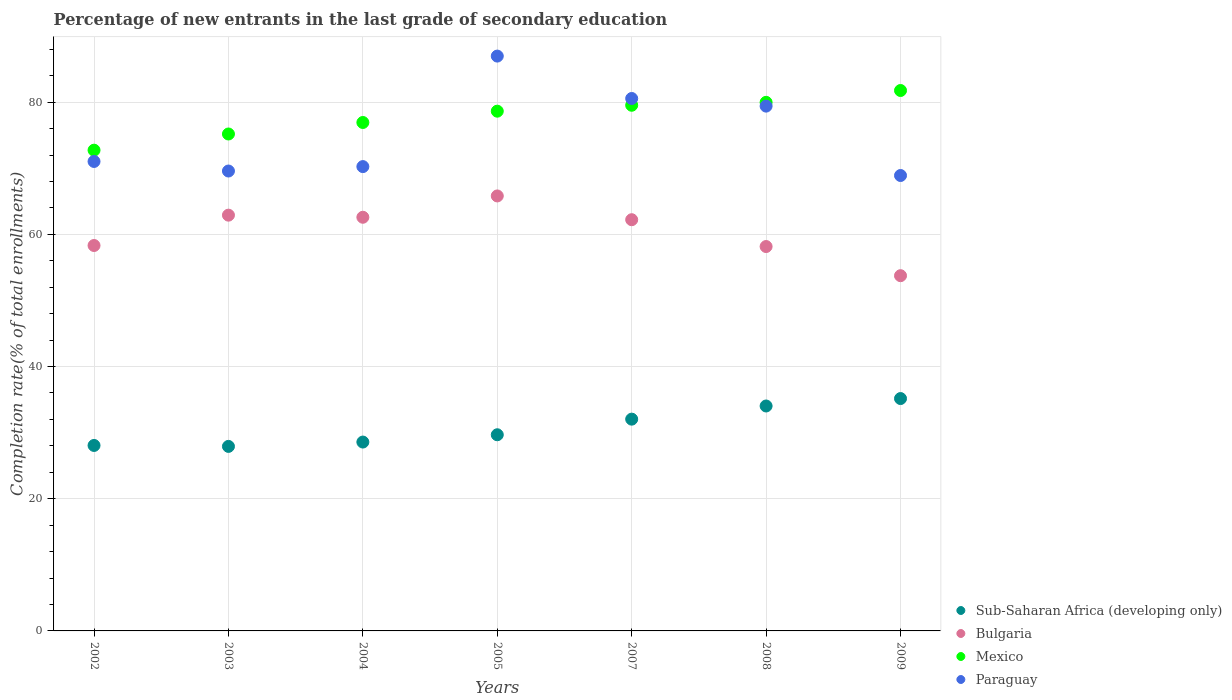How many different coloured dotlines are there?
Offer a terse response. 4. Is the number of dotlines equal to the number of legend labels?
Offer a terse response. Yes. What is the percentage of new entrants in Paraguay in 2007?
Give a very brief answer. 80.55. Across all years, what is the maximum percentage of new entrants in Bulgaria?
Your response must be concise. 65.81. Across all years, what is the minimum percentage of new entrants in Paraguay?
Offer a very short reply. 68.9. In which year was the percentage of new entrants in Sub-Saharan Africa (developing only) maximum?
Keep it short and to the point. 2009. In which year was the percentage of new entrants in Paraguay minimum?
Your answer should be very brief. 2009. What is the total percentage of new entrants in Paraguay in the graph?
Provide a succinct answer. 526.67. What is the difference between the percentage of new entrants in Mexico in 2002 and that in 2004?
Give a very brief answer. -4.19. What is the difference between the percentage of new entrants in Mexico in 2003 and the percentage of new entrants in Paraguay in 2007?
Offer a very short reply. -5.37. What is the average percentage of new entrants in Mexico per year?
Provide a succinct answer. 77.82. In the year 2004, what is the difference between the percentage of new entrants in Sub-Saharan Africa (developing only) and percentage of new entrants in Mexico?
Keep it short and to the point. -48.35. In how many years, is the percentage of new entrants in Paraguay greater than 64 %?
Your answer should be very brief. 7. What is the ratio of the percentage of new entrants in Mexico in 2002 to that in 2007?
Give a very brief answer. 0.91. Is the percentage of new entrants in Bulgaria in 2004 less than that in 2007?
Offer a terse response. No. Is the difference between the percentage of new entrants in Sub-Saharan Africa (developing only) in 2005 and 2009 greater than the difference between the percentage of new entrants in Mexico in 2005 and 2009?
Your response must be concise. No. What is the difference between the highest and the second highest percentage of new entrants in Sub-Saharan Africa (developing only)?
Make the answer very short. 1.12. What is the difference between the highest and the lowest percentage of new entrants in Sub-Saharan Africa (developing only)?
Give a very brief answer. 7.24. Is it the case that in every year, the sum of the percentage of new entrants in Sub-Saharan Africa (developing only) and percentage of new entrants in Paraguay  is greater than the sum of percentage of new entrants in Mexico and percentage of new entrants in Bulgaria?
Offer a terse response. No. Does the percentage of new entrants in Mexico monotonically increase over the years?
Offer a very short reply. Yes. Is the percentage of new entrants in Sub-Saharan Africa (developing only) strictly greater than the percentage of new entrants in Mexico over the years?
Provide a succinct answer. No. How many years are there in the graph?
Make the answer very short. 7. What is the difference between two consecutive major ticks on the Y-axis?
Your answer should be compact. 20. Does the graph contain any zero values?
Keep it short and to the point. No. Where does the legend appear in the graph?
Make the answer very short. Bottom right. How many legend labels are there?
Your response must be concise. 4. What is the title of the graph?
Give a very brief answer. Percentage of new entrants in the last grade of secondary education. Does "Kazakhstan" appear as one of the legend labels in the graph?
Your answer should be compact. No. What is the label or title of the Y-axis?
Offer a terse response. Completion rate(% of total enrollments). What is the Completion rate(% of total enrollments) in Sub-Saharan Africa (developing only) in 2002?
Ensure brevity in your answer.  28.06. What is the Completion rate(% of total enrollments) in Bulgaria in 2002?
Your answer should be very brief. 58.31. What is the Completion rate(% of total enrollments) of Mexico in 2002?
Provide a short and direct response. 72.73. What is the Completion rate(% of total enrollments) of Paraguay in 2002?
Offer a very short reply. 71.03. What is the Completion rate(% of total enrollments) in Sub-Saharan Africa (developing only) in 2003?
Offer a terse response. 27.92. What is the Completion rate(% of total enrollments) in Bulgaria in 2003?
Offer a very short reply. 62.9. What is the Completion rate(% of total enrollments) in Mexico in 2003?
Provide a succinct answer. 75.18. What is the Completion rate(% of total enrollments) in Paraguay in 2003?
Give a very brief answer. 69.58. What is the Completion rate(% of total enrollments) of Sub-Saharan Africa (developing only) in 2004?
Offer a very short reply. 28.57. What is the Completion rate(% of total enrollments) of Bulgaria in 2004?
Give a very brief answer. 62.58. What is the Completion rate(% of total enrollments) of Mexico in 2004?
Provide a succinct answer. 76.92. What is the Completion rate(% of total enrollments) of Paraguay in 2004?
Offer a terse response. 70.25. What is the Completion rate(% of total enrollments) in Sub-Saharan Africa (developing only) in 2005?
Your response must be concise. 29.68. What is the Completion rate(% of total enrollments) of Bulgaria in 2005?
Offer a terse response. 65.81. What is the Completion rate(% of total enrollments) of Mexico in 2005?
Give a very brief answer. 78.63. What is the Completion rate(% of total enrollments) in Paraguay in 2005?
Your answer should be compact. 86.97. What is the Completion rate(% of total enrollments) in Sub-Saharan Africa (developing only) in 2007?
Your response must be concise. 32.04. What is the Completion rate(% of total enrollments) in Bulgaria in 2007?
Offer a terse response. 62.21. What is the Completion rate(% of total enrollments) of Mexico in 2007?
Your answer should be compact. 79.53. What is the Completion rate(% of total enrollments) in Paraguay in 2007?
Ensure brevity in your answer.  80.55. What is the Completion rate(% of total enrollments) of Sub-Saharan Africa (developing only) in 2008?
Ensure brevity in your answer.  34.03. What is the Completion rate(% of total enrollments) in Bulgaria in 2008?
Offer a terse response. 58.15. What is the Completion rate(% of total enrollments) of Mexico in 2008?
Your response must be concise. 79.97. What is the Completion rate(% of total enrollments) of Paraguay in 2008?
Offer a very short reply. 79.4. What is the Completion rate(% of total enrollments) in Sub-Saharan Africa (developing only) in 2009?
Your response must be concise. 35.15. What is the Completion rate(% of total enrollments) of Bulgaria in 2009?
Provide a short and direct response. 53.74. What is the Completion rate(% of total enrollments) of Mexico in 2009?
Offer a terse response. 81.76. What is the Completion rate(% of total enrollments) of Paraguay in 2009?
Keep it short and to the point. 68.9. Across all years, what is the maximum Completion rate(% of total enrollments) of Sub-Saharan Africa (developing only)?
Keep it short and to the point. 35.15. Across all years, what is the maximum Completion rate(% of total enrollments) of Bulgaria?
Provide a short and direct response. 65.81. Across all years, what is the maximum Completion rate(% of total enrollments) in Mexico?
Make the answer very short. 81.76. Across all years, what is the maximum Completion rate(% of total enrollments) of Paraguay?
Give a very brief answer. 86.97. Across all years, what is the minimum Completion rate(% of total enrollments) in Sub-Saharan Africa (developing only)?
Keep it short and to the point. 27.92. Across all years, what is the minimum Completion rate(% of total enrollments) of Bulgaria?
Your response must be concise. 53.74. Across all years, what is the minimum Completion rate(% of total enrollments) in Mexico?
Give a very brief answer. 72.73. Across all years, what is the minimum Completion rate(% of total enrollments) in Paraguay?
Make the answer very short. 68.9. What is the total Completion rate(% of total enrollments) of Sub-Saharan Africa (developing only) in the graph?
Your answer should be compact. 215.45. What is the total Completion rate(% of total enrollments) in Bulgaria in the graph?
Ensure brevity in your answer.  423.72. What is the total Completion rate(% of total enrollments) in Mexico in the graph?
Your response must be concise. 544.73. What is the total Completion rate(% of total enrollments) of Paraguay in the graph?
Your answer should be very brief. 526.67. What is the difference between the Completion rate(% of total enrollments) of Sub-Saharan Africa (developing only) in 2002 and that in 2003?
Ensure brevity in your answer.  0.14. What is the difference between the Completion rate(% of total enrollments) in Bulgaria in 2002 and that in 2003?
Provide a succinct answer. -4.59. What is the difference between the Completion rate(% of total enrollments) of Mexico in 2002 and that in 2003?
Ensure brevity in your answer.  -2.45. What is the difference between the Completion rate(% of total enrollments) in Paraguay in 2002 and that in 2003?
Make the answer very short. 1.45. What is the difference between the Completion rate(% of total enrollments) in Sub-Saharan Africa (developing only) in 2002 and that in 2004?
Offer a very short reply. -0.51. What is the difference between the Completion rate(% of total enrollments) of Bulgaria in 2002 and that in 2004?
Offer a terse response. -4.27. What is the difference between the Completion rate(% of total enrollments) in Mexico in 2002 and that in 2004?
Keep it short and to the point. -4.19. What is the difference between the Completion rate(% of total enrollments) in Paraguay in 2002 and that in 2004?
Your answer should be very brief. 0.78. What is the difference between the Completion rate(% of total enrollments) of Sub-Saharan Africa (developing only) in 2002 and that in 2005?
Your response must be concise. -1.62. What is the difference between the Completion rate(% of total enrollments) of Bulgaria in 2002 and that in 2005?
Your response must be concise. -7.5. What is the difference between the Completion rate(% of total enrollments) in Mexico in 2002 and that in 2005?
Make the answer very short. -5.9. What is the difference between the Completion rate(% of total enrollments) of Paraguay in 2002 and that in 2005?
Give a very brief answer. -15.94. What is the difference between the Completion rate(% of total enrollments) of Sub-Saharan Africa (developing only) in 2002 and that in 2007?
Your answer should be compact. -3.98. What is the difference between the Completion rate(% of total enrollments) of Bulgaria in 2002 and that in 2007?
Keep it short and to the point. -3.9. What is the difference between the Completion rate(% of total enrollments) of Mexico in 2002 and that in 2007?
Provide a short and direct response. -6.8. What is the difference between the Completion rate(% of total enrollments) of Paraguay in 2002 and that in 2007?
Your response must be concise. -9.53. What is the difference between the Completion rate(% of total enrollments) in Sub-Saharan Africa (developing only) in 2002 and that in 2008?
Provide a short and direct response. -5.97. What is the difference between the Completion rate(% of total enrollments) in Bulgaria in 2002 and that in 2008?
Give a very brief answer. 0.16. What is the difference between the Completion rate(% of total enrollments) of Mexico in 2002 and that in 2008?
Give a very brief answer. -7.24. What is the difference between the Completion rate(% of total enrollments) of Paraguay in 2002 and that in 2008?
Offer a terse response. -8.37. What is the difference between the Completion rate(% of total enrollments) in Sub-Saharan Africa (developing only) in 2002 and that in 2009?
Keep it short and to the point. -7.09. What is the difference between the Completion rate(% of total enrollments) in Bulgaria in 2002 and that in 2009?
Offer a very short reply. 4.57. What is the difference between the Completion rate(% of total enrollments) of Mexico in 2002 and that in 2009?
Ensure brevity in your answer.  -9.03. What is the difference between the Completion rate(% of total enrollments) in Paraguay in 2002 and that in 2009?
Offer a very short reply. 2.13. What is the difference between the Completion rate(% of total enrollments) in Sub-Saharan Africa (developing only) in 2003 and that in 2004?
Provide a short and direct response. -0.66. What is the difference between the Completion rate(% of total enrollments) in Bulgaria in 2003 and that in 2004?
Provide a short and direct response. 0.32. What is the difference between the Completion rate(% of total enrollments) of Mexico in 2003 and that in 2004?
Your answer should be very brief. -1.74. What is the difference between the Completion rate(% of total enrollments) of Paraguay in 2003 and that in 2004?
Your response must be concise. -0.67. What is the difference between the Completion rate(% of total enrollments) in Sub-Saharan Africa (developing only) in 2003 and that in 2005?
Offer a terse response. -1.76. What is the difference between the Completion rate(% of total enrollments) of Bulgaria in 2003 and that in 2005?
Offer a very short reply. -2.91. What is the difference between the Completion rate(% of total enrollments) in Mexico in 2003 and that in 2005?
Give a very brief answer. -3.45. What is the difference between the Completion rate(% of total enrollments) of Paraguay in 2003 and that in 2005?
Provide a succinct answer. -17.39. What is the difference between the Completion rate(% of total enrollments) of Sub-Saharan Africa (developing only) in 2003 and that in 2007?
Offer a terse response. -4.12. What is the difference between the Completion rate(% of total enrollments) in Bulgaria in 2003 and that in 2007?
Your answer should be compact. 0.69. What is the difference between the Completion rate(% of total enrollments) of Mexico in 2003 and that in 2007?
Provide a succinct answer. -4.35. What is the difference between the Completion rate(% of total enrollments) in Paraguay in 2003 and that in 2007?
Offer a very short reply. -10.97. What is the difference between the Completion rate(% of total enrollments) of Sub-Saharan Africa (developing only) in 2003 and that in 2008?
Make the answer very short. -6.11. What is the difference between the Completion rate(% of total enrollments) of Bulgaria in 2003 and that in 2008?
Your answer should be compact. 4.75. What is the difference between the Completion rate(% of total enrollments) of Mexico in 2003 and that in 2008?
Ensure brevity in your answer.  -4.79. What is the difference between the Completion rate(% of total enrollments) in Paraguay in 2003 and that in 2008?
Offer a very short reply. -9.82. What is the difference between the Completion rate(% of total enrollments) in Sub-Saharan Africa (developing only) in 2003 and that in 2009?
Make the answer very short. -7.24. What is the difference between the Completion rate(% of total enrollments) in Bulgaria in 2003 and that in 2009?
Provide a short and direct response. 9.16. What is the difference between the Completion rate(% of total enrollments) of Mexico in 2003 and that in 2009?
Provide a succinct answer. -6.58. What is the difference between the Completion rate(% of total enrollments) in Paraguay in 2003 and that in 2009?
Offer a very short reply. 0.68. What is the difference between the Completion rate(% of total enrollments) of Sub-Saharan Africa (developing only) in 2004 and that in 2005?
Offer a very short reply. -1.1. What is the difference between the Completion rate(% of total enrollments) in Bulgaria in 2004 and that in 2005?
Keep it short and to the point. -3.23. What is the difference between the Completion rate(% of total enrollments) of Mexico in 2004 and that in 2005?
Provide a short and direct response. -1.71. What is the difference between the Completion rate(% of total enrollments) in Paraguay in 2004 and that in 2005?
Your answer should be compact. -16.72. What is the difference between the Completion rate(% of total enrollments) of Sub-Saharan Africa (developing only) in 2004 and that in 2007?
Make the answer very short. -3.47. What is the difference between the Completion rate(% of total enrollments) in Bulgaria in 2004 and that in 2007?
Your answer should be compact. 0.37. What is the difference between the Completion rate(% of total enrollments) in Mexico in 2004 and that in 2007?
Offer a very short reply. -2.61. What is the difference between the Completion rate(% of total enrollments) in Paraguay in 2004 and that in 2007?
Provide a succinct answer. -10.3. What is the difference between the Completion rate(% of total enrollments) in Sub-Saharan Africa (developing only) in 2004 and that in 2008?
Keep it short and to the point. -5.46. What is the difference between the Completion rate(% of total enrollments) in Bulgaria in 2004 and that in 2008?
Keep it short and to the point. 4.43. What is the difference between the Completion rate(% of total enrollments) of Mexico in 2004 and that in 2008?
Offer a very short reply. -3.05. What is the difference between the Completion rate(% of total enrollments) in Paraguay in 2004 and that in 2008?
Make the answer very short. -9.15. What is the difference between the Completion rate(% of total enrollments) of Sub-Saharan Africa (developing only) in 2004 and that in 2009?
Ensure brevity in your answer.  -6.58. What is the difference between the Completion rate(% of total enrollments) of Bulgaria in 2004 and that in 2009?
Make the answer very short. 8.84. What is the difference between the Completion rate(% of total enrollments) in Mexico in 2004 and that in 2009?
Keep it short and to the point. -4.84. What is the difference between the Completion rate(% of total enrollments) of Paraguay in 2004 and that in 2009?
Make the answer very short. 1.35. What is the difference between the Completion rate(% of total enrollments) in Sub-Saharan Africa (developing only) in 2005 and that in 2007?
Your answer should be compact. -2.36. What is the difference between the Completion rate(% of total enrollments) in Bulgaria in 2005 and that in 2007?
Give a very brief answer. 3.6. What is the difference between the Completion rate(% of total enrollments) of Mexico in 2005 and that in 2007?
Make the answer very short. -0.9. What is the difference between the Completion rate(% of total enrollments) of Paraguay in 2005 and that in 2007?
Ensure brevity in your answer.  6.42. What is the difference between the Completion rate(% of total enrollments) in Sub-Saharan Africa (developing only) in 2005 and that in 2008?
Ensure brevity in your answer.  -4.35. What is the difference between the Completion rate(% of total enrollments) of Bulgaria in 2005 and that in 2008?
Offer a very short reply. 7.65. What is the difference between the Completion rate(% of total enrollments) of Mexico in 2005 and that in 2008?
Provide a succinct answer. -1.34. What is the difference between the Completion rate(% of total enrollments) of Paraguay in 2005 and that in 2008?
Offer a very short reply. 7.57. What is the difference between the Completion rate(% of total enrollments) in Sub-Saharan Africa (developing only) in 2005 and that in 2009?
Keep it short and to the point. -5.48. What is the difference between the Completion rate(% of total enrollments) of Bulgaria in 2005 and that in 2009?
Give a very brief answer. 12.06. What is the difference between the Completion rate(% of total enrollments) of Mexico in 2005 and that in 2009?
Offer a terse response. -3.13. What is the difference between the Completion rate(% of total enrollments) in Paraguay in 2005 and that in 2009?
Keep it short and to the point. 18.07. What is the difference between the Completion rate(% of total enrollments) of Sub-Saharan Africa (developing only) in 2007 and that in 2008?
Keep it short and to the point. -1.99. What is the difference between the Completion rate(% of total enrollments) in Bulgaria in 2007 and that in 2008?
Offer a terse response. 4.06. What is the difference between the Completion rate(% of total enrollments) in Mexico in 2007 and that in 2008?
Your response must be concise. -0.44. What is the difference between the Completion rate(% of total enrollments) of Paraguay in 2007 and that in 2008?
Provide a short and direct response. 1.15. What is the difference between the Completion rate(% of total enrollments) of Sub-Saharan Africa (developing only) in 2007 and that in 2009?
Your answer should be compact. -3.12. What is the difference between the Completion rate(% of total enrollments) in Bulgaria in 2007 and that in 2009?
Your response must be concise. 8.47. What is the difference between the Completion rate(% of total enrollments) in Mexico in 2007 and that in 2009?
Provide a short and direct response. -2.23. What is the difference between the Completion rate(% of total enrollments) in Paraguay in 2007 and that in 2009?
Make the answer very short. 11.65. What is the difference between the Completion rate(% of total enrollments) in Sub-Saharan Africa (developing only) in 2008 and that in 2009?
Offer a terse response. -1.12. What is the difference between the Completion rate(% of total enrollments) in Bulgaria in 2008 and that in 2009?
Offer a very short reply. 4.41. What is the difference between the Completion rate(% of total enrollments) in Mexico in 2008 and that in 2009?
Your answer should be compact. -1.79. What is the difference between the Completion rate(% of total enrollments) in Paraguay in 2008 and that in 2009?
Provide a succinct answer. 10.5. What is the difference between the Completion rate(% of total enrollments) in Sub-Saharan Africa (developing only) in 2002 and the Completion rate(% of total enrollments) in Bulgaria in 2003?
Give a very brief answer. -34.84. What is the difference between the Completion rate(% of total enrollments) of Sub-Saharan Africa (developing only) in 2002 and the Completion rate(% of total enrollments) of Mexico in 2003?
Your response must be concise. -47.12. What is the difference between the Completion rate(% of total enrollments) of Sub-Saharan Africa (developing only) in 2002 and the Completion rate(% of total enrollments) of Paraguay in 2003?
Your response must be concise. -41.52. What is the difference between the Completion rate(% of total enrollments) of Bulgaria in 2002 and the Completion rate(% of total enrollments) of Mexico in 2003?
Your answer should be very brief. -16.87. What is the difference between the Completion rate(% of total enrollments) in Bulgaria in 2002 and the Completion rate(% of total enrollments) in Paraguay in 2003?
Your answer should be very brief. -11.27. What is the difference between the Completion rate(% of total enrollments) in Mexico in 2002 and the Completion rate(% of total enrollments) in Paraguay in 2003?
Keep it short and to the point. 3.15. What is the difference between the Completion rate(% of total enrollments) of Sub-Saharan Africa (developing only) in 2002 and the Completion rate(% of total enrollments) of Bulgaria in 2004?
Give a very brief answer. -34.52. What is the difference between the Completion rate(% of total enrollments) in Sub-Saharan Africa (developing only) in 2002 and the Completion rate(% of total enrollments) in Mexico in 2004?
Provide a short and direct response. -48.86. What is the difference between the Completion rate(% of total enrollments) of Sub-Saharan Africa (developing only) in 2002 and the Completion rate(% of total enrollments) of Paraguay in 2004?
Make the answer very short. -42.19. What is the difference between the Completion rate(% of total enrollments) in Bulgaria in 2002 and the Completion rate(% of total enrollments) in Mexico in 2004?
Offer a terse response. -18.61. What is the difference between the Completion rate(% of total enrollments) of Bulgaria in 2002 and the Completion rate(% of total enrollments) of Paraguay in 2004?
Your answer should be very brief. -11.94. What is the difference between the Completion rate(% of total enrollments) in Mexico in 2002 and the Completion rate(% of total enrollments) in Paraguay in 2004?
Offer a very short reply. 2.48. What is the difference between the Completion rate(% of total enrollments) in Sub-Saharan Africa (developing only) in 2002 and the Completion rate(% of total enrollments) in Bulgaria in 2005?
Give a very brief answer. -37.75. What is the difference between the Completion rate(% of total enrollments) of Sub-Saharan Africa (developing only) in 2002 and the Completion rate(% of total enrollments) of Mexico in 2005?
Ensure brevity in your answer.  -50.57. What is the difference between the Completion rate(% of total enrollments) of Sub-Saharan Africa (developing only) in 2002 and the Completion rate(% of total enrollments) of Paraguay in 2005?
Provide a succinct answer. -58.91. What is the difference between the Completion rate(% of total enrollments) in Bulgaria in 2002 and the Completion rate(% of total enrollments) in Mexico in 2005?
Your answer should be compact. -20.32. What is the difference between the Completion rate(% of total enrollments) of Bulgaria in 2002 and the Completion rate(% of total enrollments) of Paraguay in 2005?
Give a very brief answer. -28.66. What is the difference between the Completion rate(% of total enrollments) in Mexico in 2002 and the Completion rate(% of total enrollments) in Paraguay in 2005?
Your answer should be very brief. -14.23. What is the difference between the Completion rate(% of total enrollments) of Sub-Saharan Africa (developing only) in 2002 and the Completion rate(% of total enrollments) of Bulgaria in 2007?
Your answer should be very brief. -34.15. What is the difference between the Completion rate(% of total enrollments) of Sub-Saharan Africa (developing only) in 2002 and the Completion rate(% of total enrollments) of Mexico in 2007?
Offer a terse response. -51.47. What is the difference between the Completion rate(% of total enrollments) of Sub-Saharan Africa (developing only) in 2002 and the Completion rate(% of total enrollments) of Paraguay in 2007?
Keep it short and to the point. -52.49. What is the difference between the Completion rate(% of total enrollments) in Bulgaria in 2002 and the Completion rate(% of total enrollments) in Mexico in 2007?
Provide a succinct answer. -21.22. What is the difference between the Completion rate(% of total enrollments) in Bulgaria in 2002 and the Completion rate(% of total enrollments) in Paraguay in 2007?
Provide a short and direct response. -22.24. What is the difference between the Completion rate(% of total enrollments) of Mexico in 2002 and the Completion rate(% of total enrollments) of Paraguay in 2007?
Keep it short and to the point. -7.82. What is the difference between the Completion rate(% of total enrollments) of Sub-Saharan Africa (developing only) in 2002 and the Completion rate(% of total enrollments) of Bulgaria in 2008?
Your answer should be compact. -30.09. What is the difference between the Completion rate(% of total enrollments) in Sub-Saharan Africa (developing only) in 2002 and the Completion rate(% of total enrollments) in Mexico in 2008?
Offer a terse response. -51.91. What is the difference between the Completion rate(% of total enrollments) of Sub-Saharan Africa (developing only) in 2002 and the Completion rate(% of total enrollments) of Paraguay in 2008?
Offer a very short reply. -51.34. What is the difference between the Completion rate(% of total enrollments) in Bulgaria in 2002 and the Completion rate(% of total enrollments) in Mexico in 2008?
Give a very brief answer. -21.66. What is the difference between the Completion rate(% of total enrollments) in Bulgaria in 2002 and the Completion rate(% of total enrollments) in Paraguay in 2008?
Ensure brevity in your answer.  -21.09. What is the difference between the Completion rate(% of total enrollments) of Mexico in 2002 and the Completion rate(% of total enrollments) of Paraguay in 2008?
Provide a succinct answer. -6.67. What is the difference between the Completion rate(% of total enrollments) of Sub-Saharan Africa (developing only) in 2002 and the Completion rate(% of total enrollments) of Bulgaria in 2009?
Ensure brevity in your answer.  -25.68. What is the difference between the Completion rate(% of total enrollments) in Sub-Saharan Africa (developing only) in 2002 and the Completion rate(% of total enrollments) in Mexico in 2009?
Keep it short and to the point. -53.7. What is the difference between the Completion rate(% of total enrollments) in Sub-Saharan Africa (developing only) in 2002 and the Completion rate(% of total enrollments) in Paraguay in 2009?
Your answer should be very brief. -40.84. What is the difference between the Completion rate(% of total enrollments) in Bulgaria in 2002 and the Completion rate(% of total enrollments) in Mexico in 2009?
Keep it short and to the point. -23.45. What is the difference between the Completion rate(% of total enrollments) in Bulgaria in 2002 and the Completion rate(% of total enrollments) in Paraguay in 2009?
Provide a short and direct response. -10.59. What is the difference between the Completion rate(% of total enrollments) of Mexico in 2002 and the Completion rate(% of total enrollments) of Paraguay in 2009?
Provide a succinct answer. 3.83. What is the difference between the Completion rate(% of total enrollments) in Sub-Saharan Africa (developing only) in 2003 and the Completion rate(% of total enrollments) in Bulgaria in 2004?
Ensure brevity in your answer.  -34.67. What is the difference between the Completion rate(% of total enrollments) of Sub-Saharan Africa (developing only) in 2003 and the Completion rate(% of total enrollments) of Mexico in 2004?
Provide a succinct answer. -49. What is the difference between the Completion rate(% of total enrollments) of Sub-Saharan Africa (developing only) in 2003 and the Completion rate(% of total enrollments) of Paraguay in 2004?
Ensure brevity in your answer.  -42.33. What is the difference between the Completion rate(% of total enrollments) of Bulgaria in 2003 and the Completion rate(% of total enrollments) of Mexico in 2004?
Your answer should be very brief. -14.02. What is the difference between the Completion rate(% of total enrollments) in Bulgaria in 2003 and the Completion rate(% of total enrollments) in Paraguay in 2004?
Ensure brevity in your answer.  -7.35. What is the difference between the Completion rate(% of total enrollments) of Mexico in 2003 and the Completion rate(% of total enrollments) of Paraguay in 2004?
Offer a terse response. 4.93. What is the difference between the Completion rate(% of total enrollments) of Sub-Saharan Africa (developing only) in 2003 and the Completion rate(% of total enrollments) of Bulgaria in 2005?
Keep it short and to the point. -37.89. What is the difference between the Completion rate(% of total enrollments) of Sub-Saharan Africa (developing only) in 2003 and the Completion rate(% of total enrollments) of Mexico in 2005?
Make the answer very short. -50.72. What is the difference between the Completion rate(% of total enrollments) in Sub-Saharan Africa (developing only) in 2003 and the Completion rate(% of total enrollments) in Paraguay in 2005?
Ensure brevity in your answer.  -59.05. What is the difference between the Completion rate(% of total enrollments) in Bulgaria in 2003 and the Completion rate(% of total enrollments) in Mexico in 2005?
Your response must be concise. -15.73. What is the difference between the Completion rate(% of total enrollments) of Bulgaria in 2003 and the Completion rate(% of total enrollments) of Paraguay in 2005?
Your answer should be compact. -24.07. What is the difference between the Completion rate(% of total enrollments) of Mexico in 2003 and the Completion rate(% of total enrollments) of Paraguay in 2005?
Your answer should be very brief. -11.79. What is the difference between the Completion rate(% of total enrollments) in Sub-Saharan Africa (developing only) in 2003 and the Completion rate(% of total enrollments) in Bulgaria in 2007?
Ensure brevity in your answer.  -34.3. What is the difference between the Completion rate(% of total enrollments) in Sub-Saharan Africa (developing only) in 2003 and the Completion rate(% of total enrollments) in Mexico in 2007?
Provide a short and direct response. -51.61. What is the difference between the Completion rate(% of total enrollments) of Sub-Saharan Africa (developing only) in 2003 and the Completion rate(% of total enrollments) of Paraguay in 2007?
Your response must be concise. -52.64. What is the difference between the Completion rate(% of total enrollments) of Bulgaria in 2003 and the Completion rate(% of total enrollments) of Mexico in 2007?
Your answer should be compact. -16.63. What is the difference between the Completion rate(% of total enrollments) in Bulgaria in 2003 and the Completion rate(% of total enrollments) in Paraguay in 2007?
Provide a succinct answer. -17.65. What is the difference between the Completion rate(% of total enrollments) in Mexico in 2003 and the Completion rate(% of total enrollments) in Paraguay in 2007?
Make the answer very short. -5.37. What is the difference between the Completion rate(% of total enrollments) of Sub-Saharan Africa (developing only) in 2003 and the Completion rate(% of total enrollments) of Bulgaria in 2008?
Ensure brevity in your answer.  -30.24. What is the difference between the Completion rate(% of total enrollments) of Sub-Saharan Africa (developing only) in 2003 and the Completion rate(% of total enrollments) of Mexico in 2008?
Offer a terse response. -52.05. What is the difference between the Completion rate(% of total enrollments) of Sub-Saharan Africa (developing only) in 2003 and the Completion rate(% of total enrollments) of Paraguay in 2008?
Keep it short and to the point. -51.48. What is the difference between the Completion rate(% of total enrollments) of Bulgaria in 2003 and the Completion rate(% of total enrollments) of Mexico in 2008?
Provide a short and direct response. -17.07. What is the difference between the Completion rate(% of total enrollments) of Bulgaria in 2003 and the Completion rate(% of total enrollments) of Paraguay in 2008?
Ensure brevity in your answer.  -16.5. What is the difference between the Completion rate(% of total enrollments) of Mexico in 2003 and the Completion rate(% of total enrollments) of Paraguay in 2008?
Offer a very short reply. -4.22. What is the difference between the Completion rate(% of total enrollments) in Sub-Saharan Africa (developing only) in 2003 and the Completion rate(% of total enrollments) in Bulgaria in 2009?
Offer a very short reply. -25.83. What is the difference between the Completion rate(% of total enrollments) of Sub-Saharan Africa (developing only) in 2003 and the Completion rate(% of total enrollments) of Mexico in 2009?
Your answer should be compact. -53.84. What is the difference between the Completion rate(% of total enrollments) of Sub-Saharan Africa (developing only) in 2003 and the Completion rate(% of total enrollments) of Paraguay in 2009?
Offer a very short reply. -40.98. What is the difference between the Completion rate(% of total enrollments) of Bulgaria in 2003 and the Completion rate(% of total enrollments) of Mexico in 2009?
Offer a very short reply. -18.86. What is the difference between the Completion rate(% of total enrollments) in Bulgaria in 2003 and the Completion rate(% of total enrollments) in Paraguay in 2009?
Your answer should be very brief. -6. What is the difference between the Completion rate(% of total enrollments) of Mexico in 2003 and the Completion rate(% of total enrollments) of Paraguay in 2009?
Provide a short and direct response. 6.28. What is the difference between the Completion rate(% of total enrollments) in Sub-Saharan Africa (developing only) in 2004 and the Completion rate(% of total enrollments) in Bulgaria in 2005?
Give a very brief answer. -37.24. What is the difference between the Completion rate(% of total enrollments) of Sub-Saharan Africa (developing only) in 2004 and the Completion rate(% of total enrollments) of Mexico in 2005?
Give a very brief answer. -50.06. What is the difference between the Completion rate(% of total enrollments) in Sub-Saharan Africa (developing only) in 2004 and the Completion rate(% of total enrollments) in Paraguay in 2005?
Keep it short and to the point. -58.39. What is the difference between the Completion rate(% of total enrollments) in Bulgaria in 2004 and the Completion rate(% of total enrollments) in Mexico in 2005?
Offer a very short reply. -16.05. What is the difference between the Completion rate(% of total enrollments) of Bulgaria in 2004 and the Completion rate(% of total enrollments) of Paraguay in 2005?
Offer a terse response. -24.38. What is the difference between the Completion rate(% of total enrollments) of Mexico in 2004 and the Completion rate(% of total enrollments) of Paraguay in 2005?
Keep it short and to the point. -10.05. What is the difference between the Completion rate(% of total enrollments) in Sub-Saharan Africa (developing only) in 2004 and the Completion rate(% of total enrollments) in Bulgaria in 2007?
Your answer should be compact. -33.64. What is the difference between the Completion rate(% of total enrollments) in Sub-Saharan Africa (developing only) in 2004 and the Completion rate(% of total enrollments) in Mexico in 2007?
Your answer should be compact. -50.96. What is the difference between the Completion rate(% of total enrollments) in Sub-Saharan Africa (developing only) in 2004 and the Completion rate(% of total enrollments) in Paraguay in 2007?
Provide a short and direct response. -51.98. What is the difference between the Completion rate(% of total enrollments) of Bulgaria in 2004 and the Completion rate(% of total enrollments) of Mexico in 2007?
Give a very brief answer. -16.95. What is the difference between the Completion rate(% of total enrollments) of Bulgaria in 2004 and the Completion rate(% of total enrollments) of Paraguay in 2007?
Offer a very short reply. -17.97. What is the difference between the Completion rate(% of total enrollments) of Mexico in 2004 and the Completion rate(% of total enrollments) of Paraguay in 2007?
Offer a terse response. -3.63. What is the difference between the Completion rate(% of total enrollments) in Sub-Saharan Africa (developing only) in 2004 and the Completion rate(% of total enrollments) in Bulgaria in 2008?
Provide a short and direct response. -29.58. What is the difference between the Completion rate(% of total enrollments) of Sub-Saharan Africa (developing only) in 2004 and the Completion rate(% of total enrollments) of Mexico in 2008?
Keep it short and to the point. -51.4. What is the difference between the Completion rate(% of total enrollments) of Sub-Saharan Africa (developing only) in 2004 and the Completion rate(% of total enrollments) of Paraguay in 2008?
Provide a succinct answer. -50.83. What is the difference between the Completion rate(% of total enrollments) in Bulgaria in 2004 and the Completion rate(% of total enrollments) in Mexico in 2008?
Give a very brief answer. -17.39. What is the difference between the Completion rate(% of total enrollments) of Bulgaria in 2004 and the Completion rate(% of total enrollments) of Paraguay in 2008?
Make the answer very short. -16.82. What is the difference between the Completion rate(% of total enrollments) of Mexico in 2004 and the Completion rate(% of total enrollments) of Paraguay in 2008?
Offer a terse response. -2.48. What is the difference between the Completion rate(% of total enrollments) of Sub-Saharan Africa (developing only) in 2004 and the Completion rate(% of total enrollments) of Bulgaria in 2009?
Give a very brief answer. -25.17. What is the difference between the Completion rate(% of total enrollments) in Sub-Saharan Africa (developing only) in 2004 and the Completion rate(% of total enrollments) in Mexico in 2009?
Give a very brief answer. -53.19. What is the difference between the Completion rate(% of total enrollments) in Sub-Saharan Africa (developing only) in 2004 and the Completion rate(% of total enrollments) in Paraguay in 2009?
Make the answer very short. -40.33. What is the difference between the Completion rate(% of total enrollments) of Bulgaria in 2004 and the Completion rate(% of total enrollments) of Mexico in 2009?
Make the answer very short. -19.18. What is the difference between the Completion rate(% of total enrollments) in Bulgaria in 2004 and the Completion rate(% of total enrollments) in Paraguay in 2009?
Give a very brief answer. -6.32. What is the difference between the Completion rate(% of total enrollments) of Mexico in 2004 and the Completion rate(% of total enrollments) of Paraguay in 2009?
Offer a terse response. 8.02. What is the difference between the Completion rate(% of total enrollments) of Sub-Saharan Africa (developing only) in 2005 and the Completion rate(% of total enrollments) of Bulgaria in 2007?
Keep it short and to the point. -32.53. What is the difference between the Completion rate(% of total enrollments) of Sub-Saharan Africa (developing only) in 2005 and the Completion rate(% of total enrollments) of Mexico in 2007?
Provide a short and direct response. -49.85. What is the difference between the Completion rate(% of total enrollments) of Sub-Saharan Africa (developing only) in 2005 and the Completion rate(% of total enrollments) of Paraguay in 2007?
Offer a terse response. -50.87. What is the difference between the Completion rate(% of total enrollments) of Bulgaria in 2005 and the Completion rate(% of total enrollments) of Mexico in 2007?
Your response must be concise. -13.72. What is the difference between the Completion rate(% of total enrollments) of Bulgaria in 2005 and the Completion rate(% of total enrollments) of Paraguay in 2007?
Offer a very short reply. -14.74. What is the difference between the Completion rate(% of total enrollments) of Mexico in 2005 and the Completion rate(% of total enrollments) of Paraguay in 2007?
Make the answer very short. -1.92. What is the difference between the Completion rate(% of total enrollments) of Sub-Saharan Africa (developing only) in 2005 and the Completion rate(% of total enrollments) of Bulgaria in 2008?
Your answer should be very brief. -28.48. What is the difference between the Completion rate(% of total enrollments) in Sub-Saharan Africa (developing only) in 2005 and the Completion rate(% of total enrollments) in Mexico in 2008?
Give a very brief answer. -50.29. What is the difference between the Completion rate(% of total enrollments) of Sub-Saharan Africa (developing only) in 2005 and the Completion rate(% of total enrollments) of Paraguay in 2008?
Give a very brief answer. -49.72. What is the difference between the Completion rate(% of total enrollments) in Bulgaria in 2005 and the Completion rate(% of total enrollments) in Mexico in 2008?
Your answer should be very brief. -14.16. What is the difference between the Completion rate(% of total enrollments) of Bulgaria in 2005 and the Completion rate(% of total enrollments) of Paraguay in 2008?
Your answer should be compact. -13.59. What is the difference between the Completion rate(% of total enrollments) of Mexico in 2005 and the Completion rate(% of total enrollments) of Paraguay in 2008?
Provide a succinct answer. -0.77. What is the difference between the Completion rate(% of total enrollments) in Sub-Saharan Africa (developing only) in 2005 and the Completion rate(% of total enrollments) in Bulgaria in 2009?
Offer a terse response. -24.07. What is the difference between the Completion rate(% of total enrollments) in Sub-Saharan Africa (developing only) in 2005 and the Completion rate(% of total enrollments) in Mexico in 2009?
Offer a terse response. -52.08. What is the difference between the Completion rate(% of total enrollments) of Sub-Saharan Africa (developing only) in 2005 and the Completion rate(% of total enrollments) of Paraguay in 2009?
Provide a short and direct response. -39.22. What is the difference between the Completion rate(% of total enrollments) in Bulgaria in 2005 and the Completion rate(% of total enrollments) in Mexico in 2009?
Provide a short and direct response. -15.95. What is the difference between the Completion rate(% of total enrollments) in Bulgaria in 2005 and the Completion rate(% of total enrollments) in Paraguay in 2009?
Offer a terse response. -3.09. What is the difference between the Completion rate(% of total enrollments) of Mexico in 2005 and the Completion rate(% of total enrollments) of Paraguay in 2009?
Provide a succinct answer. 9.73. What is the difference between the Completion rate(% of total enrollments) of Sub-Saharan Africa (developing only) in 2007 and the Completion rate(% of total enrollments) of Bulgaria in 2008?
Keep it short and to the point. -26.12. What is the difference between the Completion rate(% of total enrollments) in Sub-Saharan Africa (developing only) in 2007 and the Completion rate(% of total enrollments) in Mexico in 2008?
Provide a succinct answer. -47.93. What is the difference between the Completion rate(% of total enrollments) of Sub-Saharan Africa (developing only) in 2007 and the Completion rate(% of total enrollments) of Paraguay in 2008?
Your answer should be very brief. -47.36. What is the difference between the Completion rate(% of total enrollments) in Bulgaria in 2007 and the Completion rate(% of total enrollments) in Mexico in 2008?
Offer a terse response. -17.76. What is the difference between the Completion rate(% of total enrollments) of Bulgaria in 2007 and the Completion rate(% of total enrollments) of Paraguay in 2008?
Make the answer very short. -17.19. What is the difference between the Completion rate(% of total enrollments) in Mexico in 2007 and the Completion rate(% of total enrollments) in Paraguay in 2008?
Ensure brevity in your answer.  0.13. What is the difference between the Completion rate(% of total enrollments) of Sub-Saharan Africa (developing only) in 2007 and the Completion rate(% of total enrollments) of Bulgaria in 2009?
Offer a very short reply. -21.7. What is the difference between the Completion rate(% of total enrollments) of Sub-Saharan Africa (developing only) in 2007 and the Completion rate(% of total enrollments) of Mexico in 2009?
Your answer should be very brief. -49.72. What is the difference between the Completion rate(% of total enrollments) of Sub-Saharan Africa (developing only) in 2007 and the Completion rate(% of total enrollments) of Paraguay in 2009?
Ensure brevity in your answer.  -36.86. What is the difference between the Completion rate(% of total enrollments) in Bulgaria in 2007 and the Completion rate(% of total enrollments) in Mexico in 2009?
Offer a very short reply. -19.55. What is the difference between the Completion rate(% of total enrollments) of Bulgaria in 2007 and the Completion rate(% of total enrollments) of Paraguay in 2009?
Give a very brief answer. -6.69. What is the difference between the Completion rate(% of total enrollments) in Mexico in 2007 and the Completion rate(% of total enrollments) in Paraguay in 2009?
Ensure brevity in your answer.  10.63. What is the difference between the Completion rate(% of total enrollments) of Sub-Saharan Africa (developing only) in 2008 and the Completion rate(% of total enrollments) of Bulgaria in 2009?
Keep it short and to the point. -19.71. What is the difference between the Completion rate(% of total enrollments) in Sub-Saharan Africa (developing only) in 2008 and the Completion rate(% of total enrollments) in Mexico in 2009?
Provide a succinct answer. -47.73. What is the difference between the Completion rate(% of total enrollments) in Sub-Saharan Africa (developing only) in 2008 and the Completion rate(% of total enrollments) in Paraguay in 2009?
Your answer should be compact. -34.87. What is the difference between the Completion rate(% of total enrollments) of Bulgaria in 2008 and the Completion rate(% of total enrollments) of Mexico in 2009?
Your response must be concise. -23.61. What is the difference between the Completion rate(% of total enrollments) of Bulgaria in 2008 and the Completion rate(% of total enrollments) of Paraguay in 2009?
Give a very brief answer. -10.75. What is the difference between the Completion rate(% of total enrollments) of Mexico in 2008 and the Completion rate(% of total enrollments) of Paraguay in 2009?
Keep it short and to the point. 11.07. What is the average Completion rate(% of total enrollments) of Sub-Saharan Africa (developing only) per year?
Give a very brief answer. 30.78. What is the average Completion rate(% of total enrollments) in Bulgaria per year?
Provide a short and direct response. 60.53. What is the average Completion rate(% of total enrollments) in Mexico per year?
Provide a succinct answer. 77.82. What is the average Completion rate(% of total enrollments) in Paraguay per year?
Provide a short and direct response. 75.24. In the year 2002, what is the difference between the Completion rate(% of total enrollments) of Sub-Saharan Africa (developing only) and Completion rate(% of total enrollments) of Bulgaria?
Your answer should be very brief. -30.25. In the year 2002, what is the difference between the Completion rate(% of total enrollments) in Sub-Saharan Africa (developing only) and Completion rate(% of total enrollments) in Mexico?
Offer a very short reply. -44.67. In the year 2002, what is the difference between the Completion rate(% of total enrollments) in Sub-Saharan Africa (developing only) and Completion rate(% of total enrollments) in Paraguay?
Your answer should be compact. -42.97. In the year 2002, what is the difference between the Completion rate(% of total enrollments) in Bulgaria and Completion rate(% of total enrollments) in Mexico?
Ensure brevity in your answer.  -14.42. In the year 2002, what is the difference between the Completion rate(% of total enrollments) in Bulgaria and Completion rate(% of total enrollments) in Paraguay?
Give a very brief answer. -12.71. In the year 2002, what is the difference between the Completion rate(% of total enrollments) in Mexico and Completion rate(% of total enrollments) in Paraguay?
Your answer should be compact. 1.71. In the year 2003, what is the difference between the Completion rate(% of total enrollments) in Sub-Saharan Africa (developing only) and Completion rate(% of total enrollments) in Bulgaria?
Keep it short and to the point. -34.98. In the year 2003, what is the difference between the Completion rate(% of total enrollments) in Sub-Saharan Africa (developing only) and Completion rate(% of total enrollments) in Mexico?
Your answer should be compact. -47.26. In the year 2003, what is the difference between the Completion rate(% of total enrollments) of Sub-Saharan Africa (developing only) and Completion rate(% of total enrollments) of Paraguay?
Ensure brevity in your answer.  -41.66. In the year 2003, what is the difference between the Completion rate(% of total enrollments) of Bulgaria and Completion rate(% of total enrollments) of Mexico?
Provide a succinct answer. -12.28. In the year 2003, what is the difference between the Completion rate(% of total enrollments) in Bulgaria and Completion rate(% of total enrollments) in Paraguay?
Keep it short and to the point. -6.68. In the year 2003, what is the difference between the Completion rate(% of total enrollments) of Mexico and Completion rate(% of total enrollments) of Paraguay?
Offer a very short reply. 5.6. In the year 2004, what is the difference between the Completion rate(% of total enrollments) of Sub-Saharan Africa (developing only) and Completion rate(% of total enrollments) of Bulgaria?
Provide a short and direct response. -34.01. In the year 2004, what is the difference between the Completion rate(% of total enrollments) in Sub-Saharan Africa (developing only) and Completion rate(% of total enrollments) in Mexico?
Give a very brief answer. -48.35. In the year 2004, what is the difference between the Completion rate(% of total enrollments) of Sub-Saharan Africa (developing only) and Completion rate(% of total enrollments) of Paraguay?
Ensure brevity in your answer.  -41.67. In the year 2004, what is the difference between the Completion rate(% of total enrollments) of Bulgaria and Completion rate(% of total enrollments) of Mexico?
Offer a very short reply. -14.34. In the year 2004, what is the difference between the Completion rate(% of total enrollments) in Bulgaria and Completion rate(% of total enrollments) in Paraguay?
Provide a succinct answer. -7.66. In the year 2004, what is the difference between the Completion rate(% of total enrollments) of Mexico and Completion rate(% of total enrollments) of Paraguay?
Provide a succinct answer. 6.67. In the year 2005, what is the difference between the Completion rate(% of total enrollments) of Sub-Saharan Africa (developing only) and Completion rate(% of total enrollments) of Bulgaria?
Give a very brief answer. -36.13. In the year 2005, what is the difference between the Completion rate(% of total enrollments) of Sub-Saharan Africa (developing only) and Completion rate(% of total enrollments) of Mexico?
Offer a very short reply. -48.96. In the year 2005, what is the difference between the Completion rate(% of total enrollments) of Sub-Saharan Africa (developing only) and Completion rate(% of total enrollments) of Paraguay?
Provide a succinct answer. -57.29. In the year 2005, what is the difference between the Completion rate(% of total enrollments) in Bulgaria and Completion rate(% of total enrollments) in Mexico?
Your answer should be very brief. -12.82. In the year 2005, what is the difference between the Completion rate(% of total enrollments) of Bulgaria and Completion rate(% of total enrollments) of Paraguay?
Offer a terse response. -21.16. In the year 2005, what is the difference between the Completion rate(% of total enrollments) in Mexico and Completion rate(% of total enrollments) in Paraguay?
Give a very brief answer. -8.33. In the year 2007, what is the difference between the Completion rate(% of total enrollments) of Sub-Saharan Africa (developing only) and Completion rate(% of total enrollments) of Bulgaria?
Provide a succinct answer. -30.17. In the year 2007, what is the difference between the Completion rate(% of total enrollments) in Sub-Saharan Africa (developing only) and Completion rate(% of total enrollments) in Mexico?
Offer a very short reply. -47.49. In the year 2007, what is the difference between the Completion rate(% of total enrollments) of Sub-Saharan Africa (developing only) and Completion rate(% of total enrollments) of Paraguay?
Your response must be concise. -48.51. In the year 2007, what is the difference between the Completion rate(% of total enrollments) in Bulgaria and Completion rate(% of total enrollments) in Mexico?
Your answer should be compact. -17.32. In the year 2007, what is the difference between the Completion rate(% of total enrollments) of Bulgaria and Completion rate(% of total enrollments) of Paraguay?
Ensure brevity in your answer.  -18.34. In the year 2007, what is the difference between the Completion rate(% of total enrollments) in Mexico and Completion rate(% of total enrollments) in Paraguay?
Keep it short and to the point. -1.02. In the year 2008, what is the difference between the Completion rate(% of total enrollments) in Sub-Saharan Africa (developing only) and Completion rate(% of total enrollments) in Bulgaria?
Your answer should be very brief. -24.12. In the year 2008, what is the difference between the Completion rate(% of total enrollments) in Sub-Saharan Africa (developing only) and Completion rate(% of total enrollments) in Mexico?
Make the answer very short. -45.94. In the year 2008, what is the difference between the Completion rate(% of total enrollments) in Sub-Saharan Africa (developing only) and Completion rate(% of total enrollments) in Paraguay?
Provide a short and direct response. -45.37. In the year 2008, what is the difference between the Completion rate(% of total enrollments) in Bulgaria and Completion rate(% of total enrollments) in Mexico?
Ensure brevity in your answer.  -21.82. In the year 2008, what is the difference between the Completion rate(% of total enrollments) of Bulgaria and Completion rate(% of total enrollments) of Paraguay?
Provide a succinct answer. -21.24. In the year 2008, what is the difference between the Completion rate(% of total enrollments) of Mexico and Completion rate(% of total enrollments) of Paraguay?
Your answer should be very brief. 0.57. In the year 2009, what is the difference between the Completion rate(% of total enrollments) of Sub-Saharan Africa (developing only) and Completion rate(% of total enrollments) of Bulgaria?
Provide a short and direct response. -18.59. In the year 2009, what is the difference between the Completion rate(% of total enrollments) of Sub-Saharan Africa (developing only) and Completion rate(% of total enrollments) of Mexico?
Your answer should be very brief. -46.61. In the year 2009, what is the difference between the Completion rate(% of total enrollments) in Sub-Saharan Africa (developing only) and Completion rate(% of total enrollments) in Paraguay?
Make the answer very short. -33.75. In the year 2009, what is the difference between the Completion rate(% of total enrollments) in Bulgaria and Completion rate(% of total enrollments) in Mexico?
Offer a very short reply. -28.02. In the year 2009, what is the difference between the Completion rate(% of total enrollments) in Bulgaria and Completion rate(% of total enrollments) in Paraguay?
Offer a terse response. -15.16. In the year 2009, what is the difference between the Completion rate(% of total enrollments) of Mexico and Completion rate(% of total enrollments) of Paraguay?
Your response must be concise. 12.86. What is the ratio of the Completion rate(% of total enrollments) of Sub-Saharan Africa (developing only) in 2002 to that in 2003?
Provide a short and direct response. 1.01. What is the ratio of the Completion rate(% of total enrollments) in Bulgaria in 2002 to that in 2003?
Offer a very short reply. 0.93. What is the ratio of the Completion rate(% of total enrollments) of Mexico in 2002 to that in 2003?
Your answer should be very brief. 0.97. What is the ratio of the Completion rate(% of total enrollments) in Paraguay in 2002 to that in 2003?
Your answer should be compact. 1.02. What is the ratio of the Completion rate(% of total enrollments) of Sub-Saharan Africa (developing only) in 2002 to that in 2004?
Make the answer very short. 0.98. What is the ratio of the Completion rate(% of total enrollments) in Bulgaria in 2002 to that in 2004?
Provide a succinct answer. 0.93. What is the ratio of the Completion rate(% of total enrollments) of Mexico in 2002 to that in 2004?
Offer a very short reply. 0.95. What is the ratio of the Completion rate(% of total enrollments) in Paraguay in 2002 to that in 2004?
Provide a short and direct response. 1.01. What is the ratio of the Completion rate(% of total enrollments) of Sub-Saharan Africa (developing only) in 2002 to that in 2005?
Your answer should be compact. 0.95. What is the ratio of the Completion rate(% of total enrollments) of Bulgaria in 2002 to that in 2005?
Your response must be concise. 0.89. What is the ratio of the Completion rate(% of total enrollments) in Mexico in 2002 to that in 2005?
Provide a succinct answer. 0.93. What is the ratio of the Completion rate(% of total enrollments) in Paraguay in 2002 to that in 2005?
Provide a succinct answer. 0.82. What is the ratio of the Completion rate(% of total enrollments) in Sub-Saharan Africa (developing only) in 2002 to that in 2007?
Keep it short and to the point. 0.88. What is the ratio of the Completion rate(% of total enrollments) of Bulgaria in 2002 to that in 2007?
Your answer should be very brief. 0.94. What is the ratio of the Completion rate(% of total enrollments) of Mexico in 2002 to that in 2007?
Your response must be concise. 0.91. What is the ratio of the Completion rate(% of total enrollments) in Paraguay in 2002 to that in 2007?
Ensure brevity in your answer.  0.88. What is the ratio of the Completion rate(% of total enrollments) of Sub-Saharan Africa (developing only) in 2002 to that in 2008?
Make the answer very short. 0.82. What is the ratio of the Completion rate(% of total enrollments) of Mexico in 2002 to that in 2008?
Offer a terse response. 0.91. What is the ratio of the Completion rate(% of total enrollments) in Paraguay in 2002 to that in 2008?
Ensure brevity in your answer.  0.89. What is the ratio of the Completion rate(% of total enrollments) of Sub-Saharan Africa (developing only) in 2002 to that in 2009?
Your answer should be very brief. 0.8. What is the ratio of the Completion rate(% of total enrollments) in Bulgaria in 2002 to that in 2009?
Provide a short and direct response. 1.08. What is the ratio of the Completion rate(% of total enrollments) in Mexico in 2002 to that in 2009?
Provide a short and direct response. 0.89. What is the ratio of the Completion rate(% of total enrollments) of Paraguay in 2002 to that in 2009?
Provide a succinct answer. 1.03. What is the ratio of the Completion rate(% of total enrollments) of Sub-Saharan Africa (developing only) in 2003 to that in 2004?
Ensure brevity in your answer.  0.98. What is the ratio of the Completion rate(% of total enrollments) of Mexico in 2003 to that in 2004?
Provide a short and direct response. 0.98. What is the ratio of the Completion rate(% of total enrollments) in Paraguay in 2003 to that in 2004?
Keep it short and to the point. 0.99. What is the ratio of the Completion rate(% of total enrollments) in Sub-Saharan Africa (developing only) in 2003 to that in 2005?
Ensure brevity in your answer.  0.94. What is the ratio of the Completion rate(% of total enrollments) of Bulgaria in 2003 to that in 2005?
Your answer should be very brief. 0.96. What is the ratio of the Completion rate(% of total enrollments) in Mexico in 2003 to that in 2005?
Provide a succinct answer. 0.96. What is the ratio of the Completion rate(% of total enrollments) of Paraguay in 2003 to that in 2005?
Your answer should be compact. 0.8. What is the ratio of the Completion rate(% of total enrollments) in Sub-Saharan Africa (developing only) in 2003 to that in 2007?
Your answer should be compact. 0.87. What is the ratio of the Completion rate(% of total enrollments) in Bulgaria in 2003 to that in 2007?
Ensure brevity in your answer.  1.01. What is the ratio of the Completion rate(% of total enrollments) in Mexico in 2003 to that in 2007?
Make the answer very short. 0.95. What is the ratio of the Completion rate(% of total enrollments) in Paraguay in 2003 to that in 2007?
Provide a short and direct response. 0.86. What is the ratio of the Completion rate(% of total enrollments) in Sub-Saharan Africa (developing only) in 2003 to that in 2008?
Ensure brevity in your answer.  0.82. What is the ratio of the Completion rate(% of total enrollments) of Bulgaria in 2003 to that in 2008?
Keep it short and to the point. 1.08. What is the ratio of the Completion rate(% of total enrollments) in Mexico in 2003 to that in 2008?
Provide a succinct answer. 0.94. What is the ratio of the Completion rate(% of total enrollments) in Paraguay in 2003 to that in 2008?
Give a very brief answer. 0.88. What is the ratio of the Completion rate(% of total enrollments) in Sub-Saharan Africa (developing only) in 2003 to that in 2009?
Provide a succinct answer. 0.79. What is the ratio of the Completion rate(% of total enrollments) in Bulgaria in 2003 to that in 2009?
Offer a terse response. 1.17. What is the ratio of the Completion rate(% of total enrollments) in Mexico in 2003 to that in 2009?
Make the answer very short. 0.92. What is the ratio of the Completion rate(% of total enrollments) in Paraguay in 2003 to that in 2009?
Provide a succinct answer. 1.01. What is the ratio of the Completion rate(% of total enrollments) in Sub-Saharan Africa (developing only) in 2004 to that in 2005?
Your response must be concise. 0.96. What is the ratio of the Completion rate(% of total enrollments) in Bulgaria in 2004 to that in 2005?
Your answer should be very brief. 0.95. What is the ratio of the Completion rate(% of total enrollments) of Mexico in 2004 to that in 2005?
Your answer should be very brief. 0.98. What is the ratio of the Completion rate(% of total enrollments) in Paraguay in 2004 to that in 2005?
Provide a short and direct response. 0.81. What is the ratio of the Completion rate(% of total enrollments) of Sub-Saharan Africa (developing only) in 2004 to that in 2007?
Offer a terse response. 0.89. What is the ratio of the Completion rate(% of total enrollments) of Bulgaria in 2004 to that in 2007?
Make the answer very short. 1.01. What is the ratio of the Completion rate(% of total enrollments) in Mexico in 2004 to that in 2007?
Your answer should be compact. 0.97. What is the ratio of the Completion rate(% of total enrollments) in Paraguay in 2004 to that in 2007?
Give a very brief answer. 0.87. What is the ratio of the Completion rate(% of total enrollments) in Sub-Saharan Africa (developing only) in 2004 to that in 2008?
Give a very brief answer. 0.84. What is the ratio of the Completion rate(% of total enrollments) of Bulgaria in 2004 to that in 2008?
Ensure brevity in your answer.  1.08. What is the ratio of the Completion rate(% of total enrollments) of Mexico in 2004 to that in 2008?
Provide a short and direct response. 0.96. What is the ratio of the Completion rate(% of total enrollments) of Paraguay in 2004 to that in 2008?
Provide a succinct answer. 0.88. What is the ratio of the Completion rate(% of total enrollments) in Sub-Saharan Africa (developing only) in 2004 to that in 2009?
Ensure brevity in your answer.  0.81. What is the ratio of the Completion rate(% of total enrollments) in Bulgaria in 2004 to that in 2009?
Keep it short and to the point. 1.16. What is the ratio of the Completion rate(% of total enrollments) in Mexico in 2004 to that in 2009?
Provide a short and direct response. 0.94. What is the ratio of the Completion rate(% of total enrollments) of Paraguay in 2004 to that in 2009?
Provide a short and direct response. 1.02. What is the ratio of the Completion rate(% of total enrollments) in Sub-Saharan Africa (developing only) in 2005 to that in 2007?
Your response must be concise. 0.93. What is the ratio of the Completion rate(% of total enrollments) of Bulgaria in 2005 to that in 2007?
Keep it short and to the point. 1.06. What is the ratio of the Completion rate(% of total enrollments) in Mexico in 2005 to that in 2007?
Your answer should be very brief. 0.99. What is the ratio of the Completion rate(% of total enrollments) in Paraguay in 2005 to that in 2007?
Provide a short and direct response. 1.08. What is the ratio of the Completion rate(% of total enrollments) of Sub-Saharan Africa (developing only) in 2005 to that in 2008?
Your response must be concise. 0.87. What is the ratio of the Completion rate(% of total enrollments) of Bulgaria in 2005 to that in 2008?
Your answer should be very brief. 1.13. What is the ratio of the Completion rate(% of total enrollments) of Mexico in 2005 to that in 2008?
Provide a short and direct response. 0.98. What is the ratio of the Completion rate(% of total enrollments) of Paraguay in 2005 to that in 2008?
Give a very brief answer. 1.1. What is the ratio of the Completion rate(% of total enrollments) of Sub-Saharan Africa (developing only) in 2005 to that in 2009?
Make the answer very short. 0.84. What is the ratio of the Completion rate(% of total enrollments) of Bulgaria in 2005 to that in 2009?
Make the answer very short. 1.22. What is the ratio of the Completion rate(% of total enrollments) of Mexico in 2005 to that in 2009?
Your answer should be very brief. 0.96. What is the ratio of the Completion rate(% of total enrollments) of Paraguay in 2005 to that in 2009?
Keep it short and to the point. 1.26. What is the ratio of the Completion rate(% of total enrollments) in Sub-Saharan Africa (developing only) in 2007 to that in 2008?
Your answer should be very brief. 0.94. What is the ratio of the Completion rate(% of total enrollments) of Bulgaria in 2007 to that in 2008?
Your response must be concise. 1.07. What is the ratio of the Completion rate(% of total enrollments) of Paraguay in 2007 to that in 2008?
Your answer should be compact. 1.01. What is the ratio of the Completion rate(% of total enrollments) of Sub-Saharan Africa (developing only) in 2007 to that in 2009?
Keep it short and to the point. 0.91. What is the ratio of the Completion rate(% of total enrollments) of Bulgaria in 2007 to that in 2009?
Make the answer very short. 1.16. What is the ratio of the Completion rate(% of total enrollments) in Mexico in 2007 to that in 2009?
Your response must be concise. 0.97. What is the ratio of the Completion rate(% of total enrollments) in Paraguay in 2007 to that in 2009?
Ensure brevity in your answer.  1.17. What is the ratio of the Completion rate(% of total enrollments) of Sub-Saharan Africa (developing only) in 2008 to that in 2009?
Provide a succinct answer. 0.97. What is the ratio of the Completion rate(% of total enrollments) in Bulgaria in 2008 to that in 2009?
Ensure brevity in your answer.  1.08. What is the ratio of the Completion rate(% of total enrollments) in Mexico in 2008 to that in 2009?
Provide a succinct answer. 0.98. What is the ratio of the Completion rate(% of total enrollments) of Paraguay in 2008 to that in 2009?
Offer a terse response. 1.15. What is the difference between the highest and the second highest Completion rate(% of total enrollments) in Sub-Saharan Africa (developing only)?
Your answer should be very brief. 1.12. What is the difference between the highest and the second highest Completion rate(% of total enrollments) of Bulgaria?
Offer a terse response. 2.91. What is the difference between the highest and the second highest Completion rate(% of total enrollments) in Mexico?
Your response must be concise. 1.79. What is the difference between the highest and the second highest Completion rate(% of total enrollments) of Paraguay?
Your answer should be very brief. 6.42. What is the difference between the highest and the lowest Completion rate(% of total enrollments) of Sub-Saharan Africa (developing only)?
Give a very brief answer. 7.24. What is the difference between the highest and the lowest Completion rate(% of total enrollments) of Bulgaria?
Your response must be concise. 12.06. What is the difference between the highest and the lowest Completion rate(% of total enrollments) in Mexico?
Offer a very short reply. 9.03. What is the difference between the highest and the lowest Completion rate(% of total enrollments) of Paraguay?
Provide a short and direct response. 18.07. 